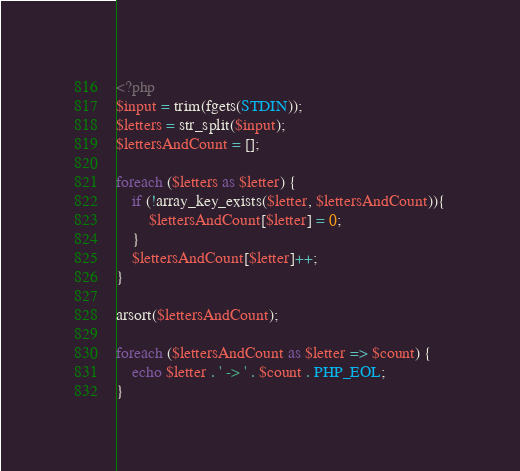Convert code to text. <code><loc_0><loc_0><loc_500><loc_500><_PHP_><?php
$input = trim(fgets(STDIN));
$letters = str_split($input);
$lettersAndCount = [];

foreach ($letters as $letter) {
    if (!array_key_exists($letter, $lettersAndCount)){
        $lettersAndCount[$letter] = 0;
    }
    $lettersAndCount[$letter]++;
}

arsort($lettersAndCount);

foreach ($lettersAndCount as $letter => $count) {
    echo $letter . ' -> ' . $count . PHP_EOL;
}</code> 